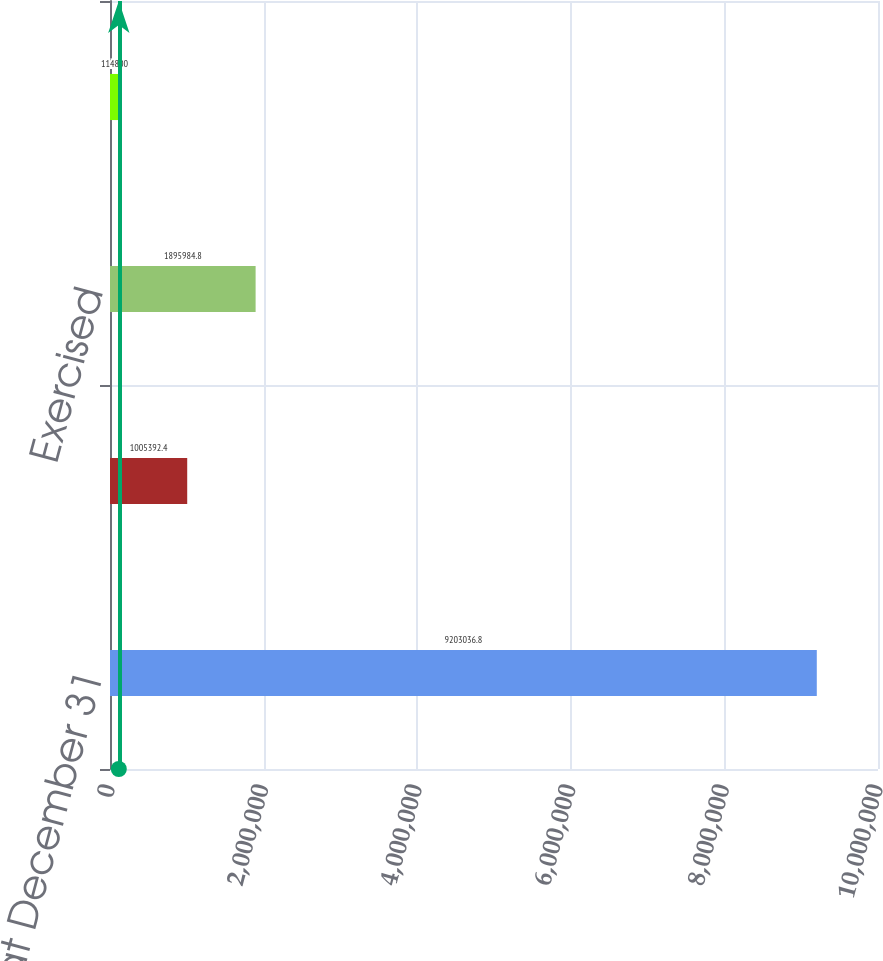Convert chart. <chart><loc_0><loc_0><loc_500><loc_500><bar_chart><fcel>Outstanding at December 31<fcel>Granted<fcel>Exercised<fcel>Terminated<nl><fcel>9.20304e+06<fcel>1.00539e+06<fcel>1.89598e+06<fcel>114800<nl></chart> 